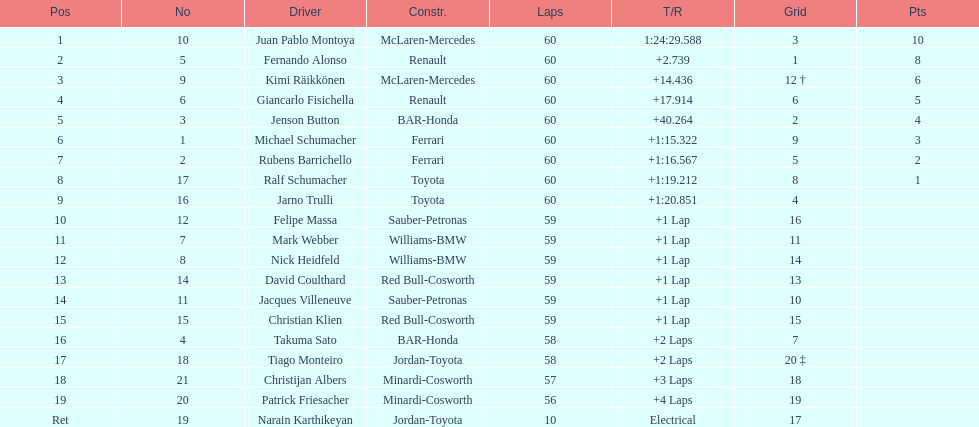What is the number of toyota's on the list? 4. 